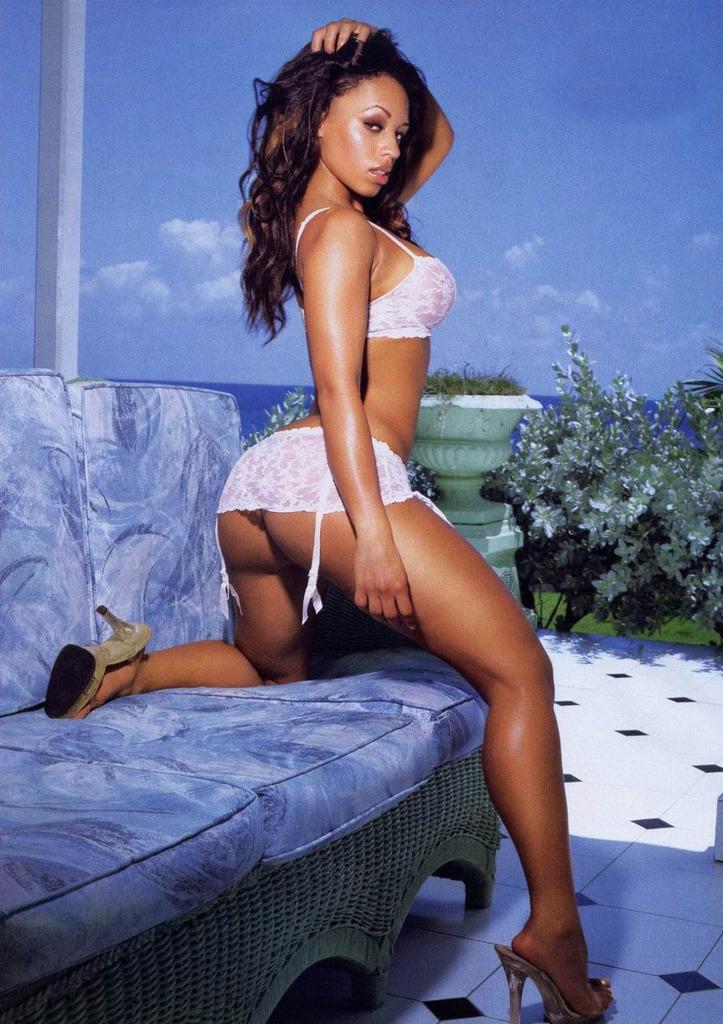Could you give a brief overview of what you see in this image? In this picture there is a women and she has placed her one leg on a sofa. At the background there are flower pots. 